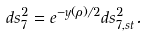Convert formula to latex. <formula><loc_0><loc_0><loc_500><loc_500>d s _ { 7 } ^ { 2 } = e ^ { - y ( \rho ) / 2 } d s _ { 7 , s t } ^ { 2 } .</formula> 